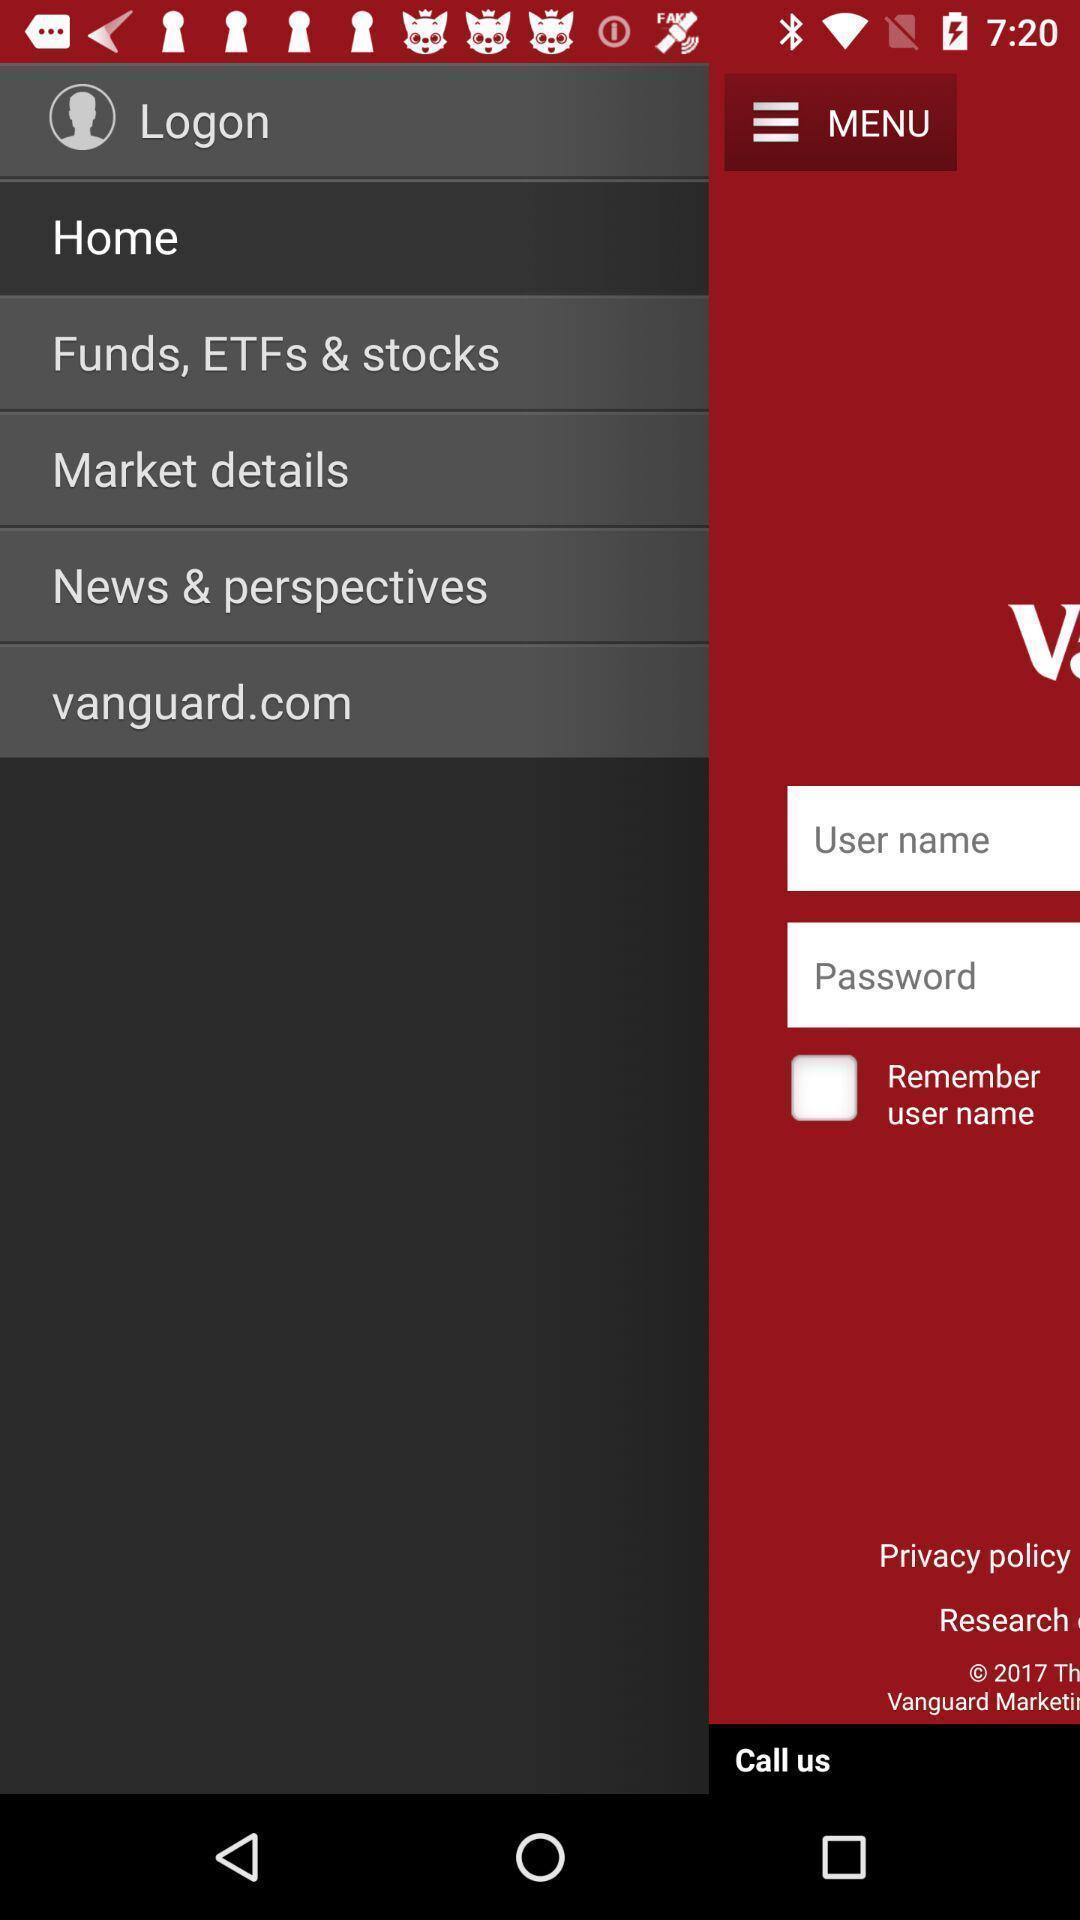Tell me what you see in this picture. Page displayed the various funds and marketing details news. 